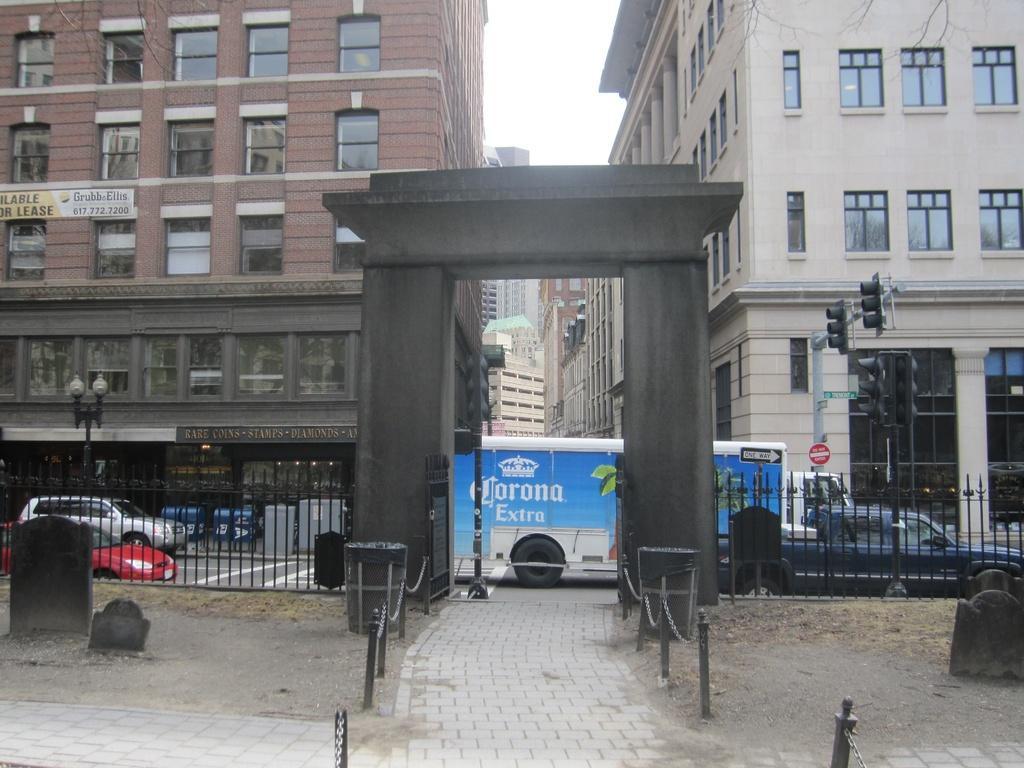Describe this image in one or two sentences. In this picture there is a arch in the center with a lane. On both the sides of the lane there are poles and baskets. On either side of the image, there is a fence. Behind the fence there are vehicles like buses and cars. Towards the left and right there are buildings which are in cream and brown in color. In the background there are buildings and sky. 